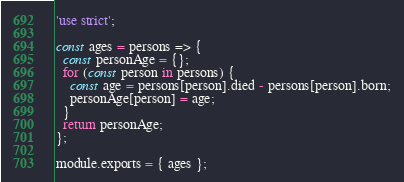Convert code to text. <code><loc_0><loc_0><loc_500><loc_500><_JavaScript_>'use strict';

const ages = persons => {
  const personAge = {};
  for (const person in persons) {
    const age = persons[person].died - persons[person].born;
    personAge[person] = age;
  }
  return personAge;
};

module.exports = { ages };
</code> 